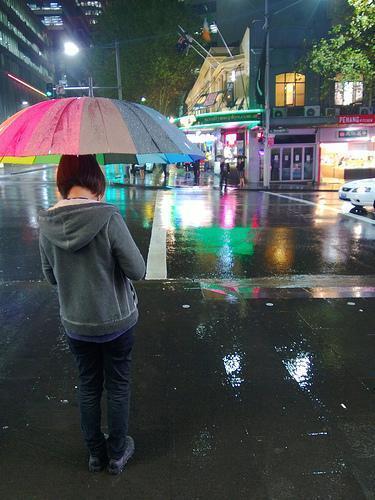How many cars do you see?
Give a very brief answer. 1. 